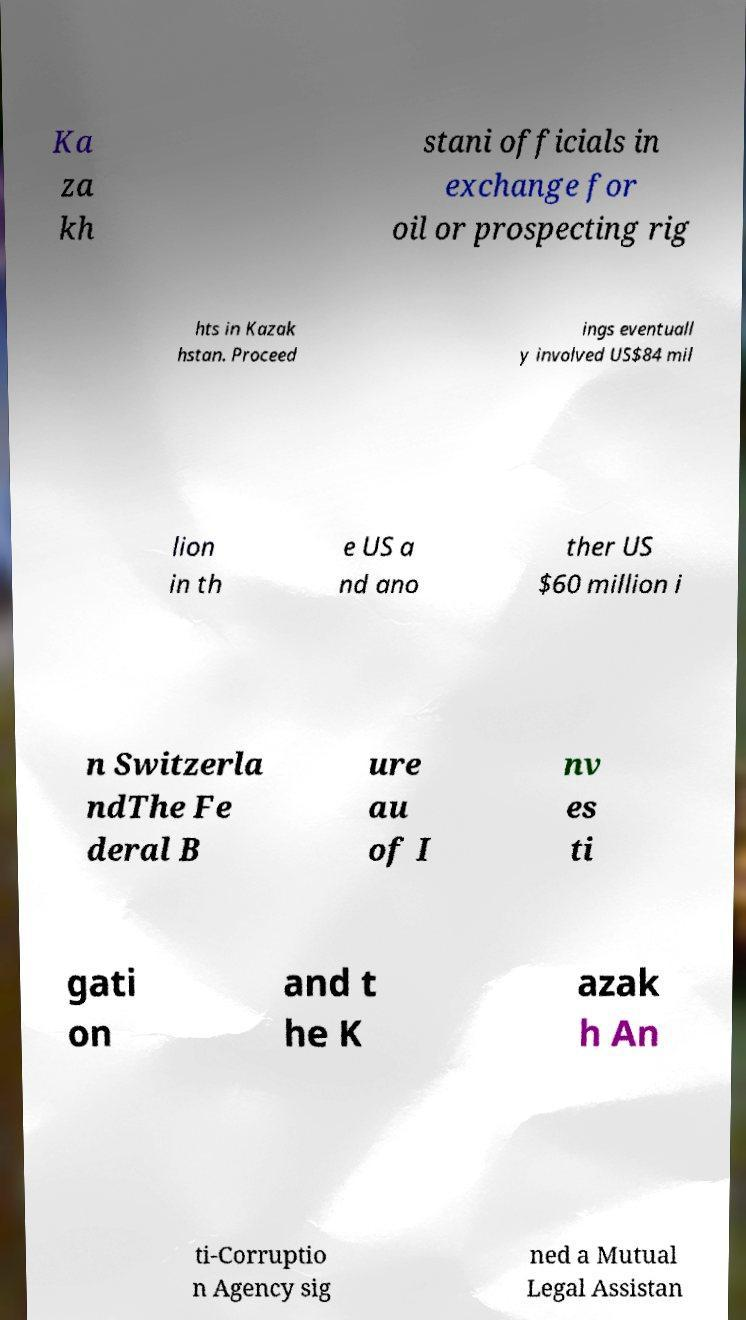Can you read and provide the text displayed in the image?This photo seems to have some interesting text. Can you extract and type it out for me? Ka za kh stani officials in exchange for oil or prospecting rig hts in Kazak hstan. Proceed ings eventuall y involved US$84 mil lion in th e US a nd ano ther US $60 million i n Switzerla ndThe Fe deral B ure au of I nv es ti gati on and t he K azak h An ti-Corruptio n Agency sig ned a Mutual Legal Assistan 